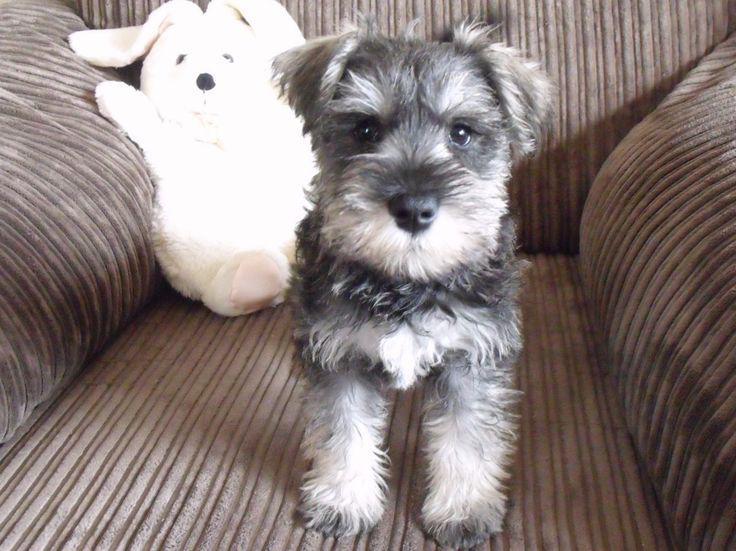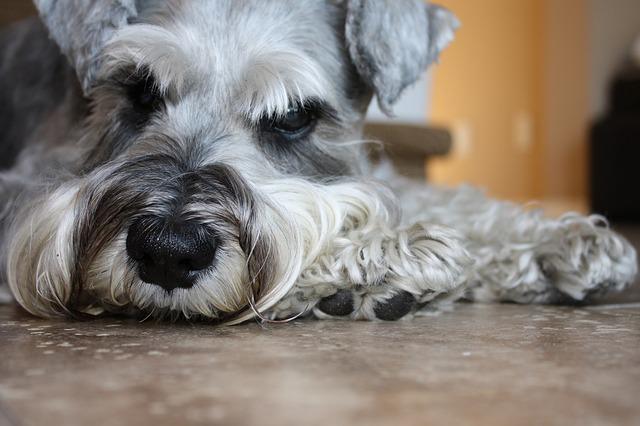The first image is the image on the left, the second image is the image on the right. Considering the images on both sides, is "An image shows an animal with all-white fur." valid? Answer yes or no. Yes. 